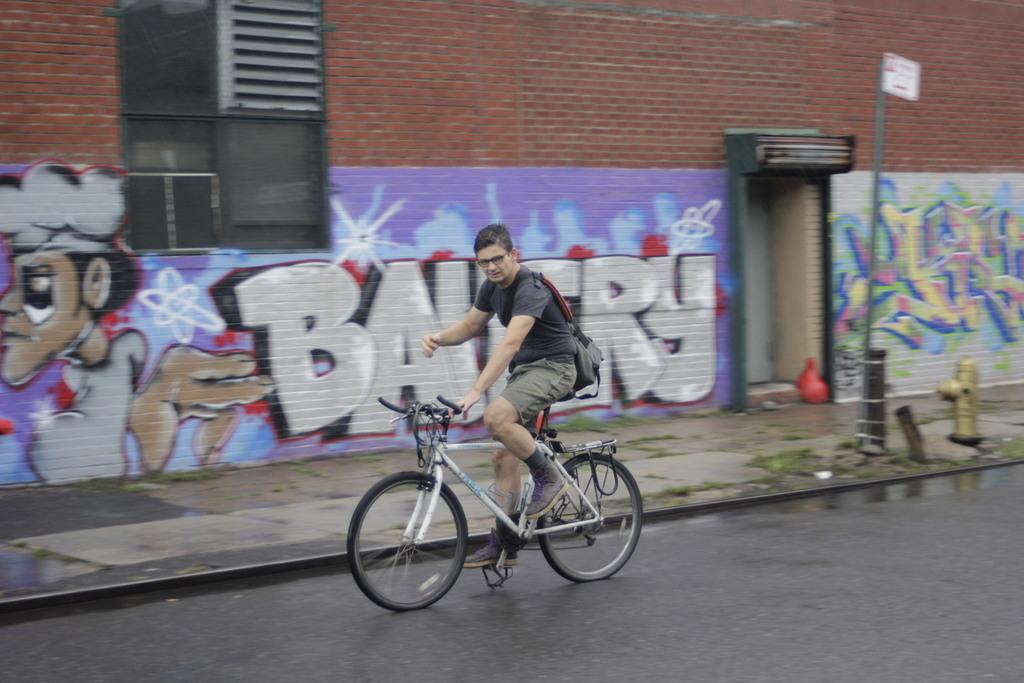Can you describe this image briefly? Here is the man wearing backpack bag and riding bicycle. This is a building with a window. I can see a hydrant which is gold in color. This is a pole. This looks like a wall a painting. I can see a red color object here. 